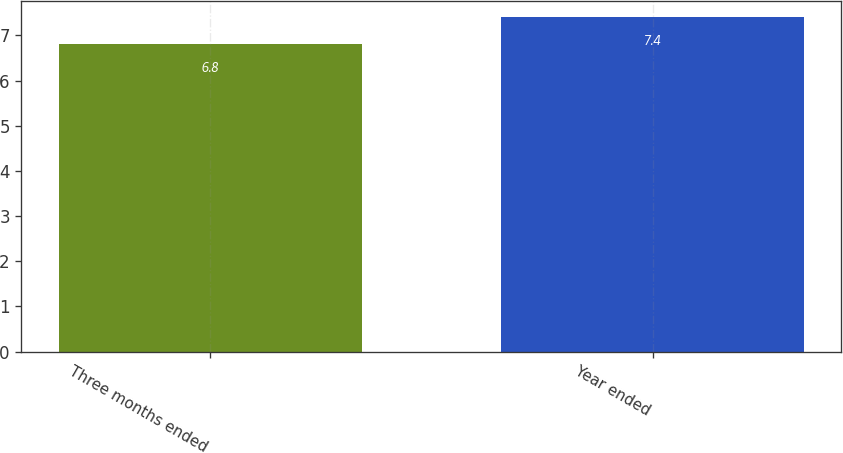Convert chart to OTSL. <chart><loc_0><loc_0><loc_500><loc_500><bar_chart><fcel>Three months ended<fcel>Year ended<nl><fcel>6.8<fcel>7.4<nl></chart> 